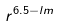Convert formula to latex. <formula><loc_0><loc_0><loc_500><loc_500>r ^ { 6 . 5 - l m }</formula> 